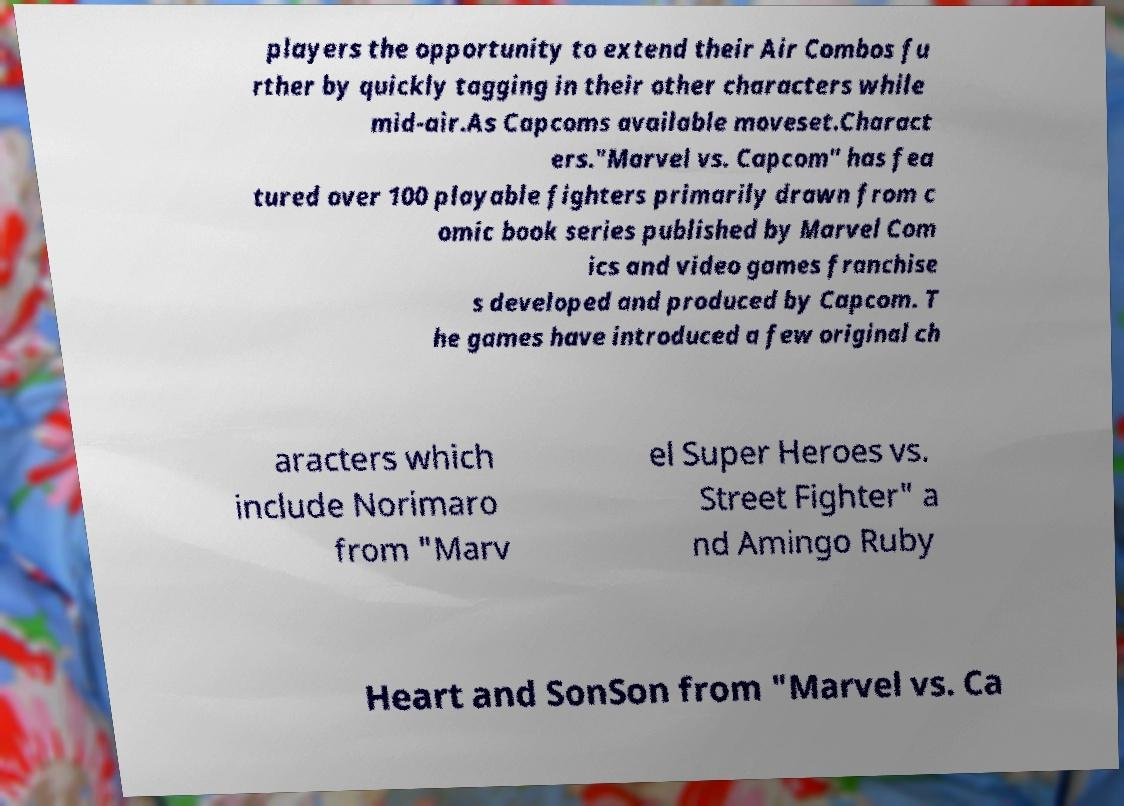For documentation purposes, I need the text within this image transcribed. Could you provide that? players the opportunity to extend their Air Combos fu rther by quickly tagging in their other characters while mid-air.As Capcoms available moveset.Charact ers."Marvel vs. Capcom" has fea tured over 100 playable fighters primarily drawn from c omic book series published by Marvel Com ics and video games franchise s developed and produced by Capcom. T he games have introduced a few original ch aracters which include Norimaro from "Marv el Super Heroes vs. Street Fighter" a nd Amingo Ruby Heart and SonSon from "Marvel vs. Ca 